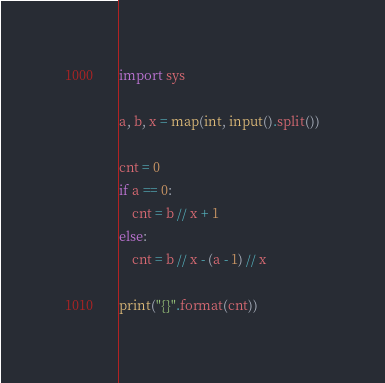Convert code to text. <code><loc_0><loc_0><loc_500><loc_500><_Python_>import sys

a, b, x = map(int, input().split())

cnt = 0
if a == 0:
    cnt = b // x + 1
else:
    cnt = b // x - (a - 1) // x

print("{}".format(cnt))</code> 